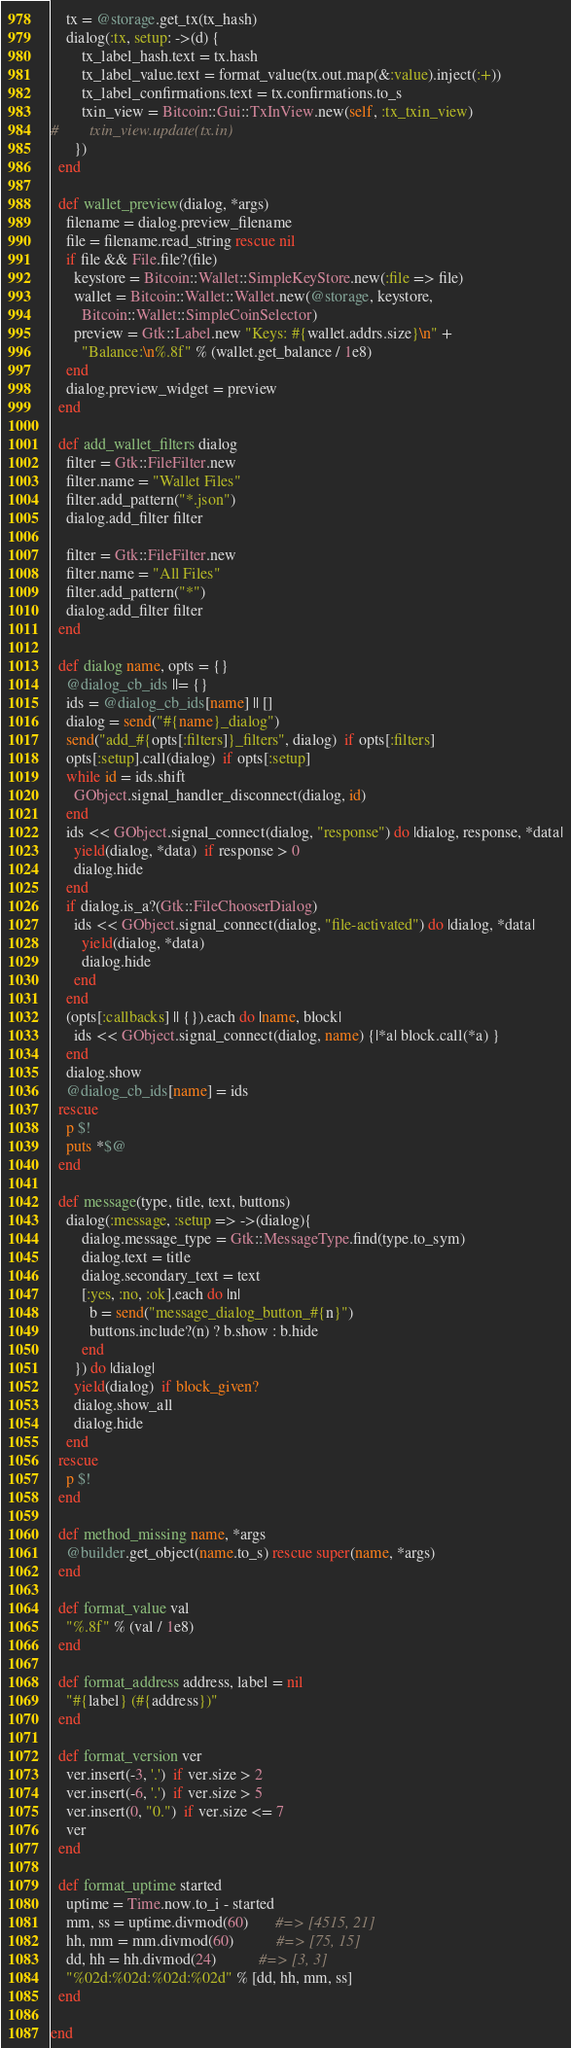<code> <loc_0><loc_0><loc_500><loc_500><_Ruby_>    tx = @storage.get_tx(tx_hash)
    dialog(:tx, setup: ->(d) {
        tx_label_hash.text = tx.hash
        tx_label_value.text = format_value(tx.out.map(&:value).inject(:+))
        tx_label_confirmations.text = tx.confirmations.to_s
        txin_view = Bitcoin::Gui::TxInView.new(self, :tx_txin_view)
#        txin_view.update(tx.in)
      })
  end

  def wallet_preview(dialog, *args)
    filename = dialog.preview_filename
    file = filename.read_string rescue nil
    if file && File.file?(file)
      keystore = Bitcoin::Wallet::SimpleKeyStore.new(:file => file)
      wallet = Bitcoin::Wallet::Wallet.new(@storage, keystore,
        Bitcoin::Wallet::SimpleCoinSelector)
      preview = Gtk::Label.new "Keys: #{wallet.addrs.size}\n" +
        "Balance:\n%.8f" % (wallet.get_balance / 1e8)
    end
    dialog.preview_widget = preview
  end

  def add_wallet_filters dialog
    filter = Gtk::FileFilter.new
    filter.name = "Wallet Files"
    filter.add_pattern("*.json")
    dialog.add_filter filter

    filter = Gtk::FileFilter.new
    filter.name = "All Files"
    filter.add_pattern("*")
    dialog.add_filter filter
  end

  def dialog name, opts = {}
    @dialog_cb_ids ||= {}
    ids = @dialog_cb_ids[name] || []
    dialog = send("#{name}_dialog")
    send("add_#{opts[:filters]}_filters", dialog)  if opts[:filters]
    opts[:setup].call(dialog)  if opts[:setup]
    while id = ids.shift
      GObject.signal_handler_disconnect(dialog, id)
    end
    ids << GObject.signal_connect(dialog, "response") do |dialog, response, *data|
      yield(dialog, *data)  if response > 0
      dialog.hide
    end
    if dialog.is_a?(Gtk::FileChooserDialog)
      ids << GObject.signal_connect(dialog, "file-activated") do |dialog, *data|
        yield(dialog, *data)
        dialog.hide
      end
    end
    (opts[:callbacks] || {}).each do |name, block|
      ids << GObject.signal_connect(dialog, name) {|*a| block.call(*a) }
    end
    dialog.show
    @dialog_cb_ids[name] = ids
  rescue
    p $!
    puts *$@
  end

  def message(type, title, text, buttons)
    dialog(:message, :setup => ->(dialog){
        dialog.message_type = Gtk::MessageType.find(type.to_sym)
        dialog.text = title
        dialog.secondary_text = text
        [:yes, :no, :ok].each do |n|
          b = send("message_dialog_button_#{n}")
          buttons.include?(n) ? b.show : b.hide
        end
      }) do |dialog|
      yield(dialog)  if block_given?
      dialog.show_all
      dialog.hide
    end
  rescue
    p $!
  end

  def method_missing name, *args
    @builder.get_object(name.to_s) rescue super(name, *args)
  end

  def format_value val
    "%.8f" % (val / 1e8)
  end

  def format_address address, label = nil
    "#{label} (#{address})"
  end

  def format_version ver
    ver.insert(-3, '.')  if ver.size > 2
    ver.insert(-6, '.')  if ver.size > 5
    ver.insert(0, "0.")  if ver.size <= 7
    ver
  end

  def format_uptime started
    uptime = Time.now.to_i - started
    mm, ss = uptime.divmod(60)       #=> [4515, 21]
    hh, mm = mm.divmod(60)           #=> [75, 15]
    dd, hh = hh.divmod(24)           #=> [3, 3]
    "%02d:%02d:%02d:%02d" % [dd, hh, mm, ss]
  end

end
</code> 